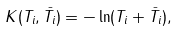<formula> <loc_0><loc_0><loc_500><loc_500>K ( T _ { i } , \bar { T } _ { i } ) = - \ln ( T _ { i } + \bar { T } _ { i } ) ,</formula> 